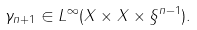Convert formula to latex. <formula><loc_0><loc_0><loc_500><loc_500>\gamma _ { n + 1 } \in L ^ { \infty } ( X \times X \times \S ^ { n - 1 } ) .</formula> 